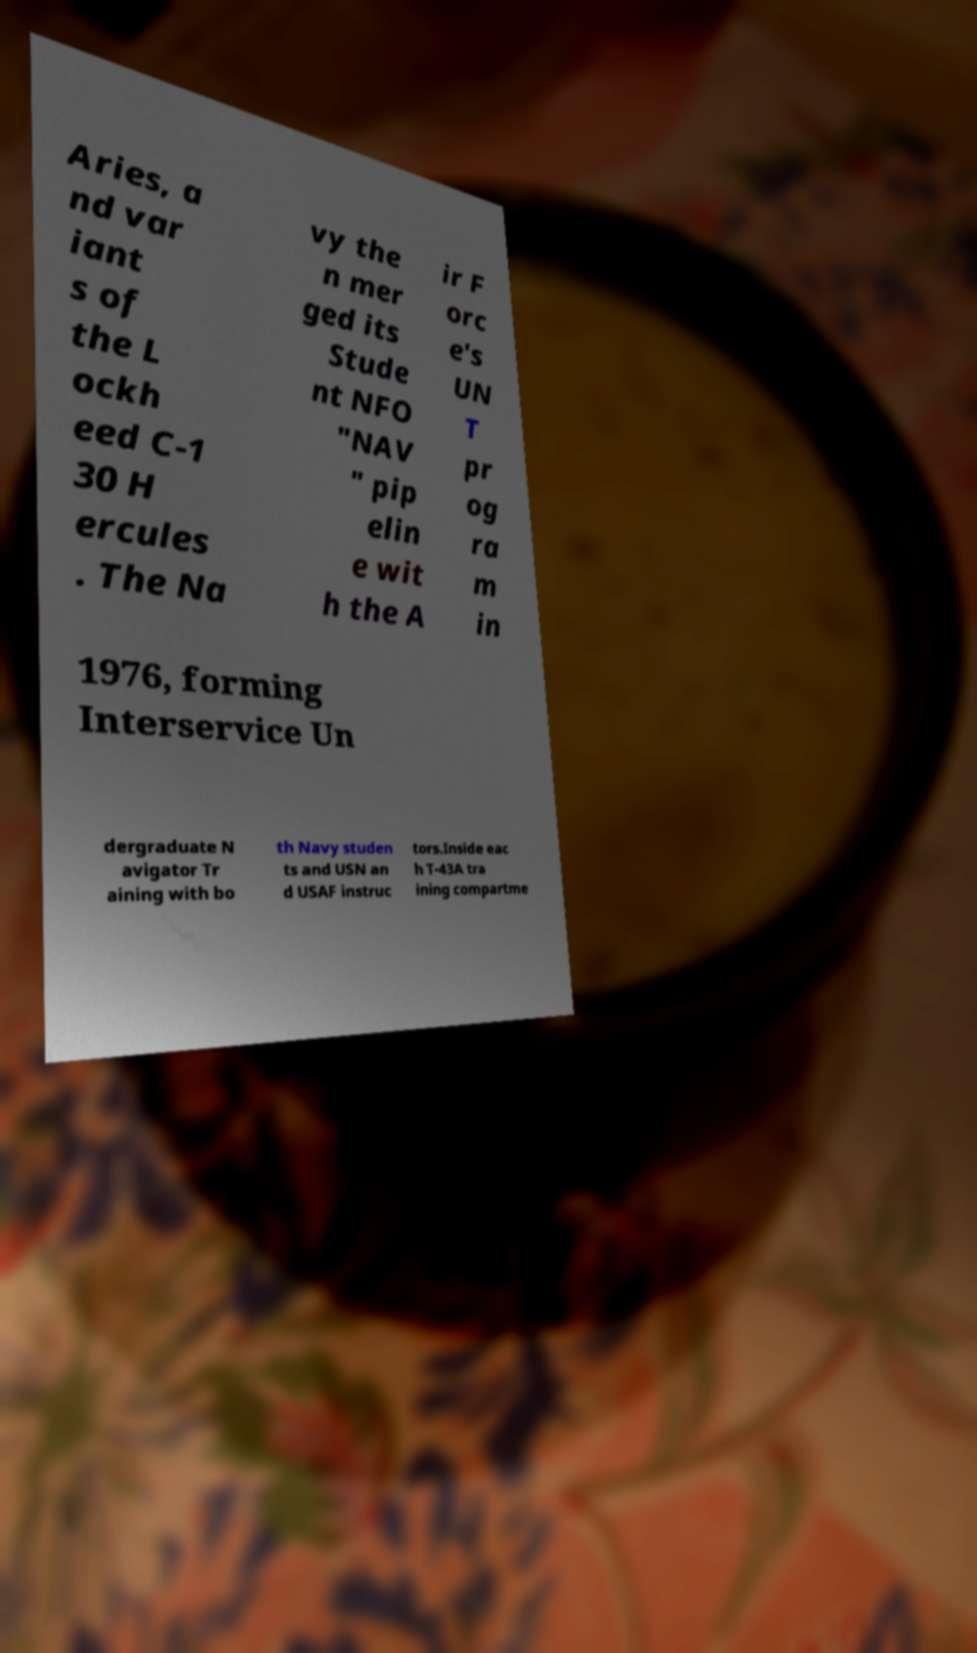Could you extract and type out the text from this image? Aries, a nd var iant s of the L ockh eed C-1 30 H ercules . The Na vy the n mer ged its Stude nt NFO "NAV " pip elin e wit h the A ir F orc e's UN T pr og ra m in 1976, forming Interservice Un dergraduate N avigator Tr aining with bo th Navy studen ts and USN an d USAF instruc tors.Inside eac h T-43A tra ining compartme 